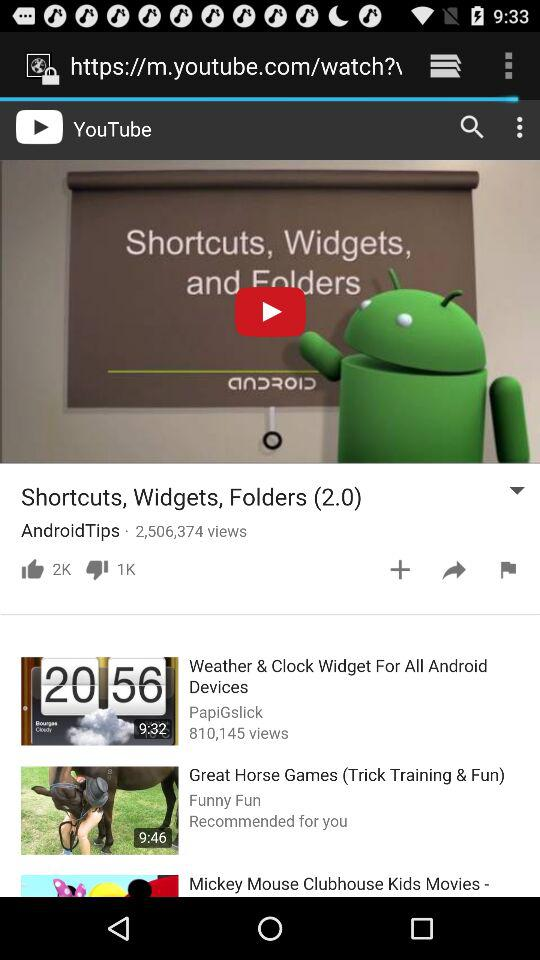What is the title of the current video? The title of the current video is "Shortcuts, Widgets, Folders (2.0)". 